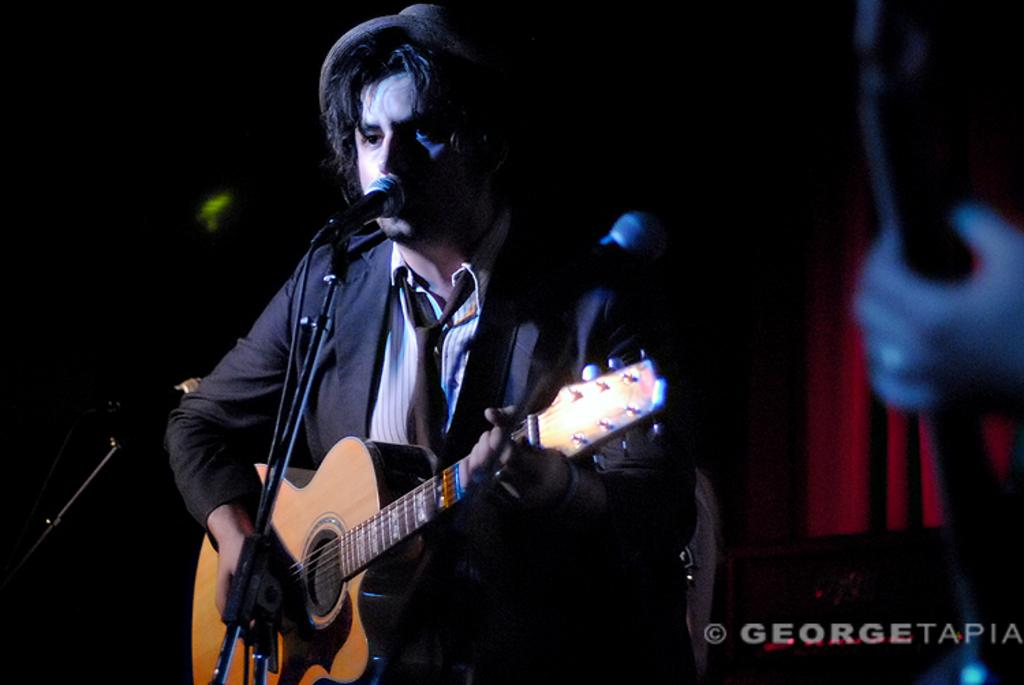What is the man in the image doing? The man is playing a guitar and singing on a microphone. Can you describe the other person in the image? There is a person in the bottom right side of the image, and they are holding something in their hands. What might the person be holding in their hands? It is not clear from the image what the person is holding, but it could be a musical instrument, a microphone, or another object related to the performance. What type of property is being sold in the image? There is no property being sold in the image; it features a man playing a guitar and singing on a microphone, and another person holding something in their hands. Is there a kettle visible in the image? No, there is no kettle present in the image. 